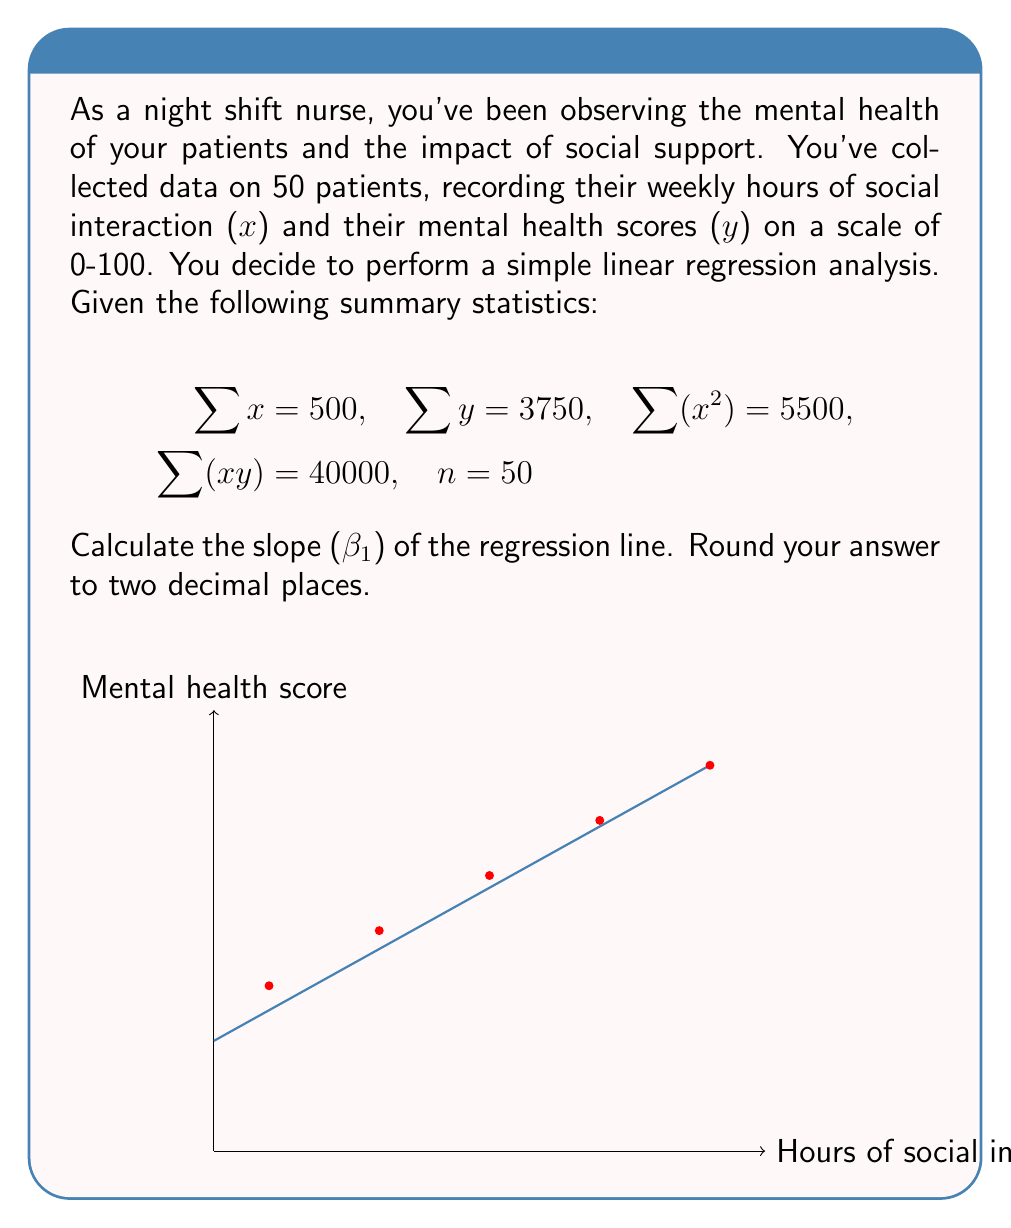Can you answer this question? To calculate the slope (β₁) of the regression line, we'll use the formula:

$$ \beta_1 = \frac{n\sum(xy) - \sum x \sum y}{n\sum(x^2) - (\sum x)^2} $$

Let's substitute the given values:

n = 50
∑x = 500
∑y = 3750
∑(x²) = 5500
∑(xy) = 40000

Step 1: Calculate the numerator
$$ n\sum(xy) - \sum x \sum y = 50(40000) - 500(3750) = 2000000 - 1875000 = 125000 $$

Step 2: Calculate the denominator
$$ n\sum(x^2) - (\sum x)^2 = 50(5500) - 500^2 = 275000 - 250000 = 25000 $$

Step 3: Divide the numerator by the denominator
$$ \beta_1 = \frac{125000}{25000} = 5 $$

Therefore, the slope of the regression line is 5.
Answer: $\beta_1 = 5.00$ 